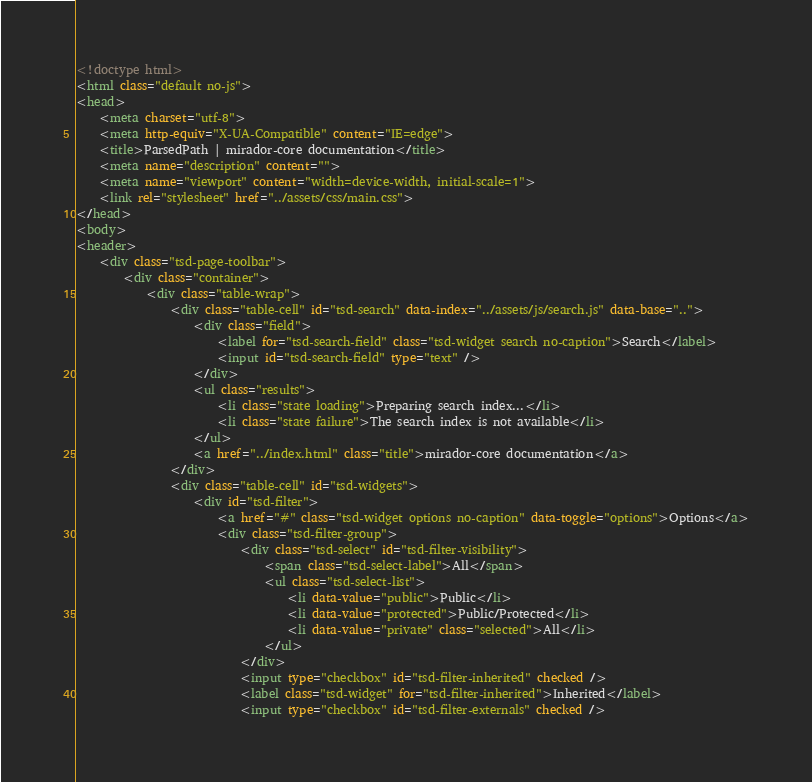Convert code to text. <code><loc_0><loc_0><loc_500><loc_500><_HTML_><!doctype html>
<html class="default no-js">
<head>
	<meta charset="utf-8">
	<meta http-equiv="X-UA-Compatible" content="IE=edge">
	<title>ParsedPath | mirador-core documentation</title>
	<meta name="description" content="">
	<meta name="viewport" content="width=device-width, initial-scale=1">
	<link rel="stylesheet" href="../assets/css/main.css">
</head>
<body>
<header>
	<div class="tsd-page-toolbar">
		<div class="container">
			<div class="table-wrap">
				<div class="table-cell" id="tsd-search" data-index="../assets/js/search.js" data-base="..">
					<div class="field">
						<label for="tsd-search-field" class="tsd-widget search no-caption">Search</label>
						<input id="tsd-search-field" type="text" />
					</div>
					<ul class="results">
						<li class="state loading">Preparing search index...</li>
						<li class="state failure">The search index is not available</li>
					</ul>
					<a href="../index.html" class="title">mirador-core documentation</a>
				</div>
				<div class="table-cell" id="tsd-widgets">
					<div id="tsd-filter">
						<a href="#" class="tsd-widget options no-caption" data-toggle="options">Options</a>
						<div class="tsd-filter-group">
							<div class="tsd-select" id="tsd-filter-visibility">
								<span class="tsd-select-label">All</span>
								<ul class="tsd-select-list">
									<li data-value="public">Public</li>
									<li data-value="protected">Public/Protected</li>
									<li data-value="private" class="selected">All</li>
								</ul>
							</div>
							<input type="checkbox" id="tsd-filter-inherited" checked />
							<label class="tsd-widget" for="tsd-filter-inherited">Inherited</label>
							<input type="checkbox" id="tsd-filter-externals" checked /></code> 